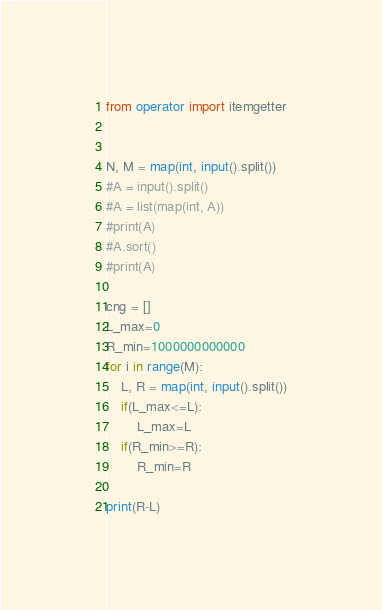<code> <loc_0><loc_0><loc_500><loc_500><_Python_>from operator import itemgetter
              

N, M = map(int, input().split())
#A = input().split()
#A = list(map(int, A))
#print(A)
#A.sort()
#print(A)

cng = []
L_max=0
R_min=1000000000000
for i in range(M):
    L, R = map(int, input().split())
    if(L_max<=L):
        L_max=L
    if(R_min>=R):
        R_min=R
        
print(R-L)</code> 